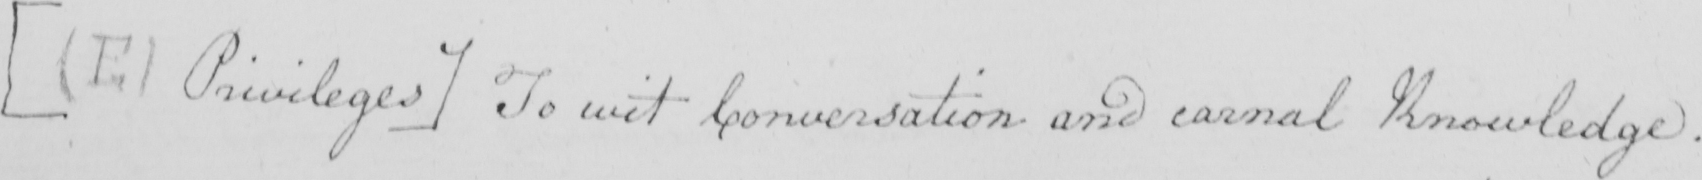What is written in this line of handwriting? [  ( E )  Privileges ]  To wit Conversation and carnal Knowledge . 